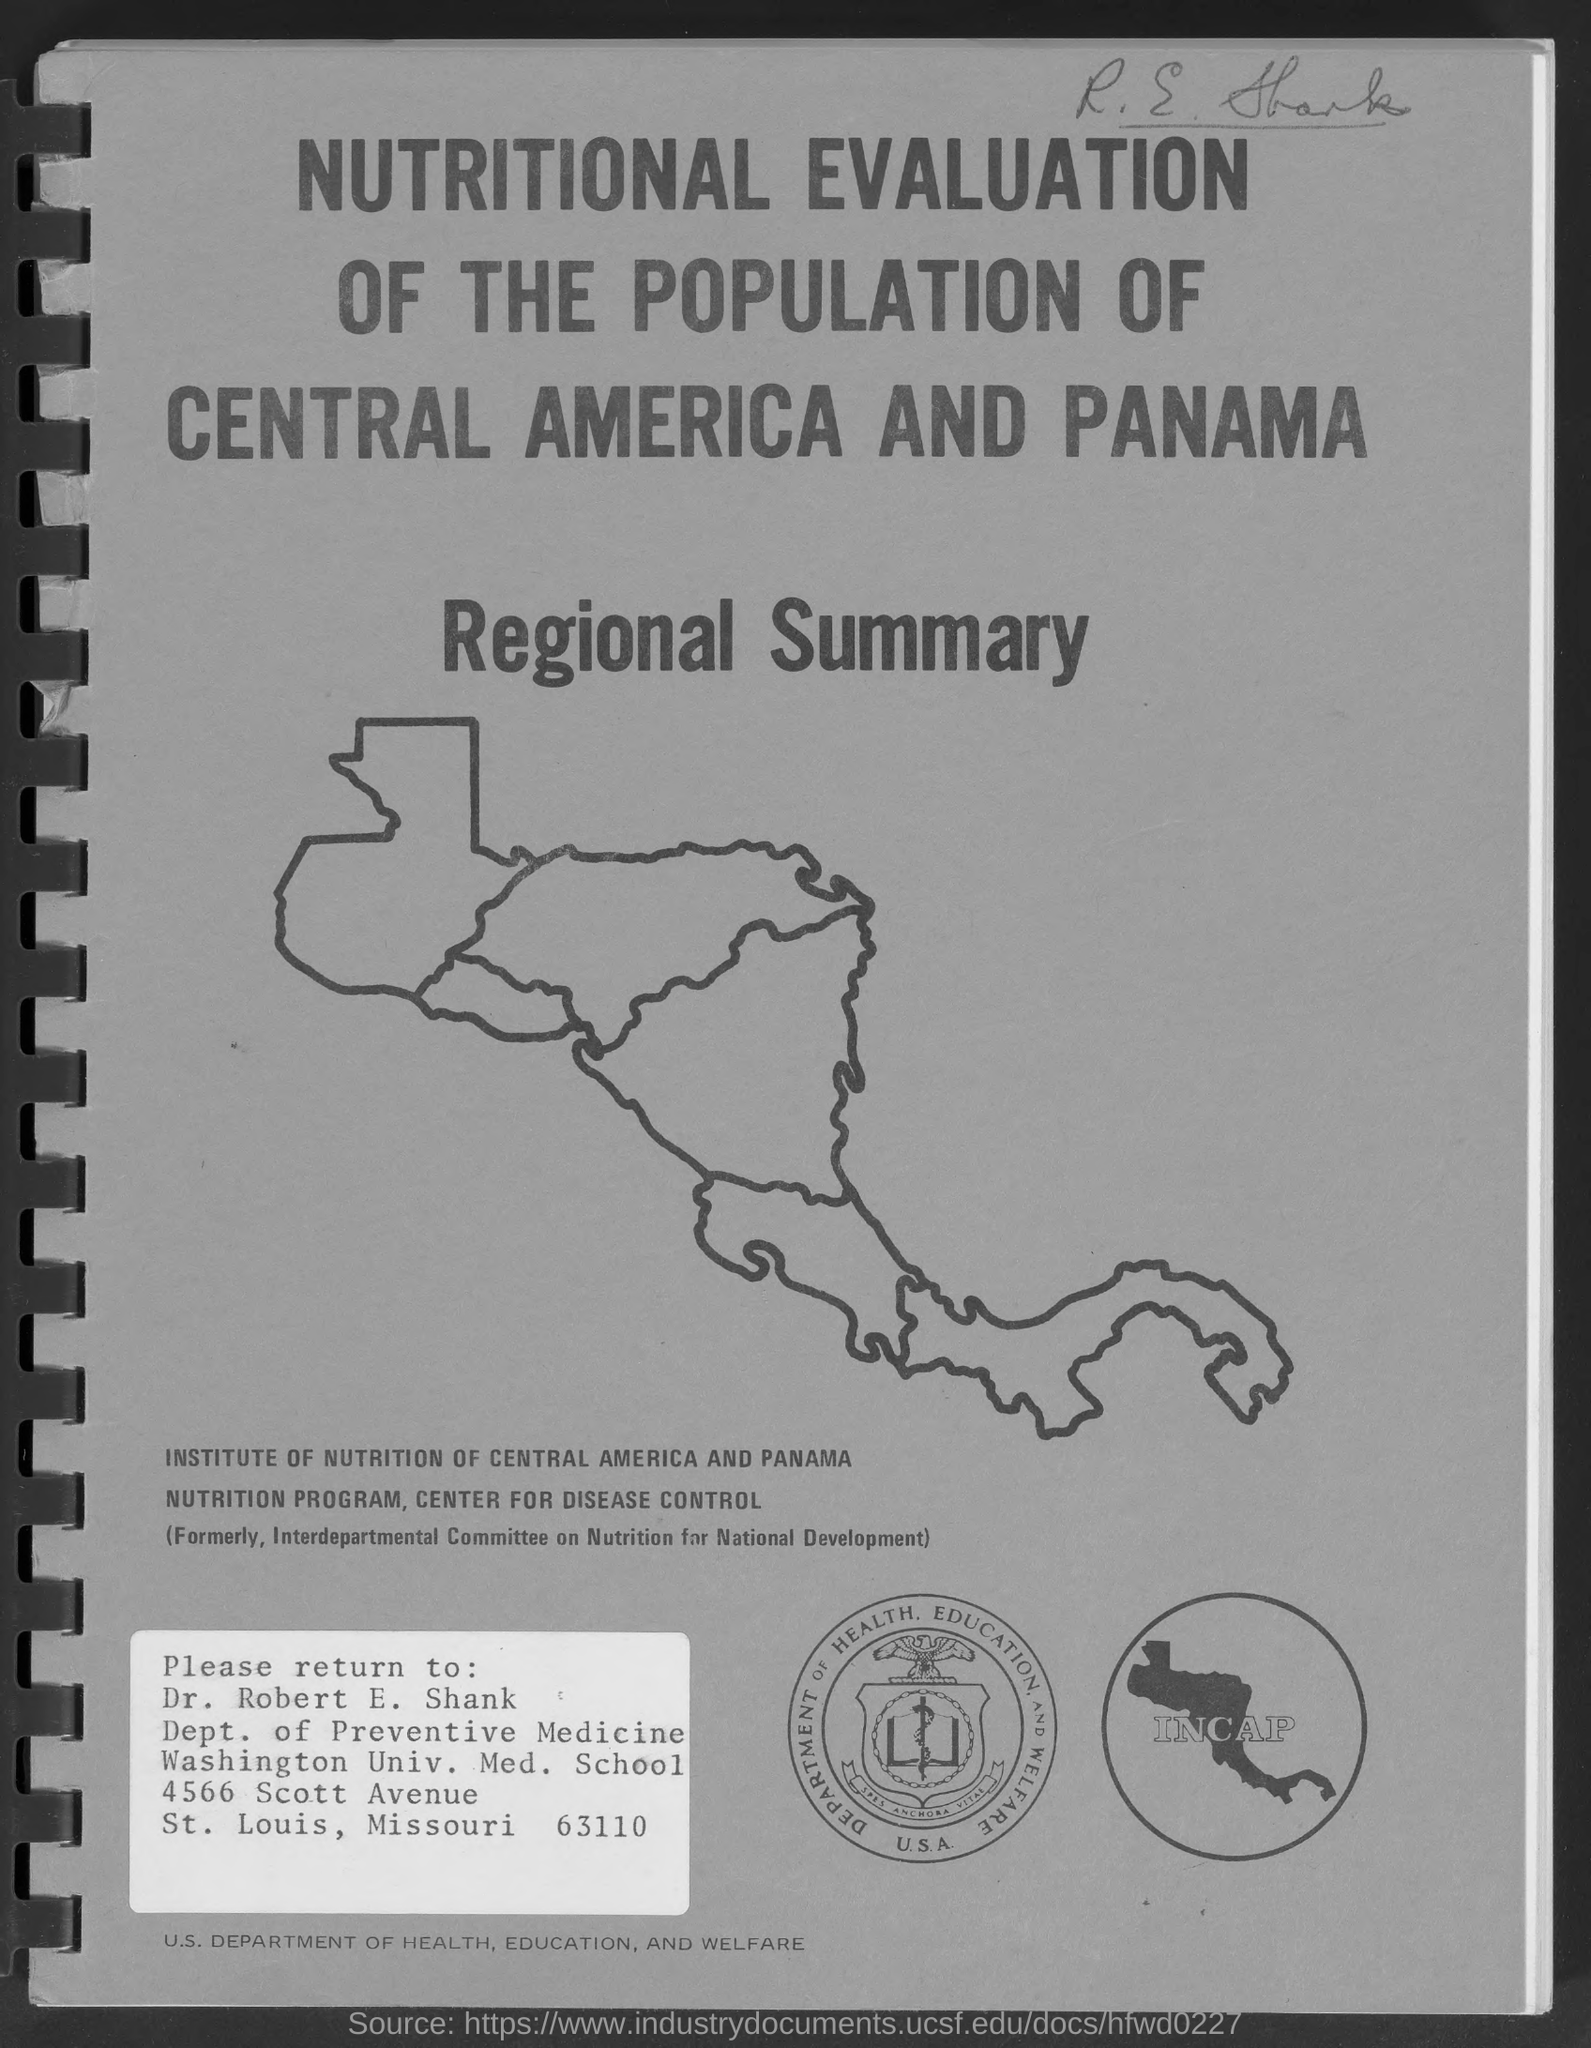Identify some key points in this picture. Dr. Robert E. Shank belongs to the Department of Preventive Medicine. The Institute of Nutrition of Central America and Panama was previously known as the Interdepartmental Committee on Nutrition for National Development. The acronym "INCAP" stands for the Institute of Nutrition of Central America and Panama, which is a research and education organization focused on improving the nutritional status of individuals in Central America and Panama. 